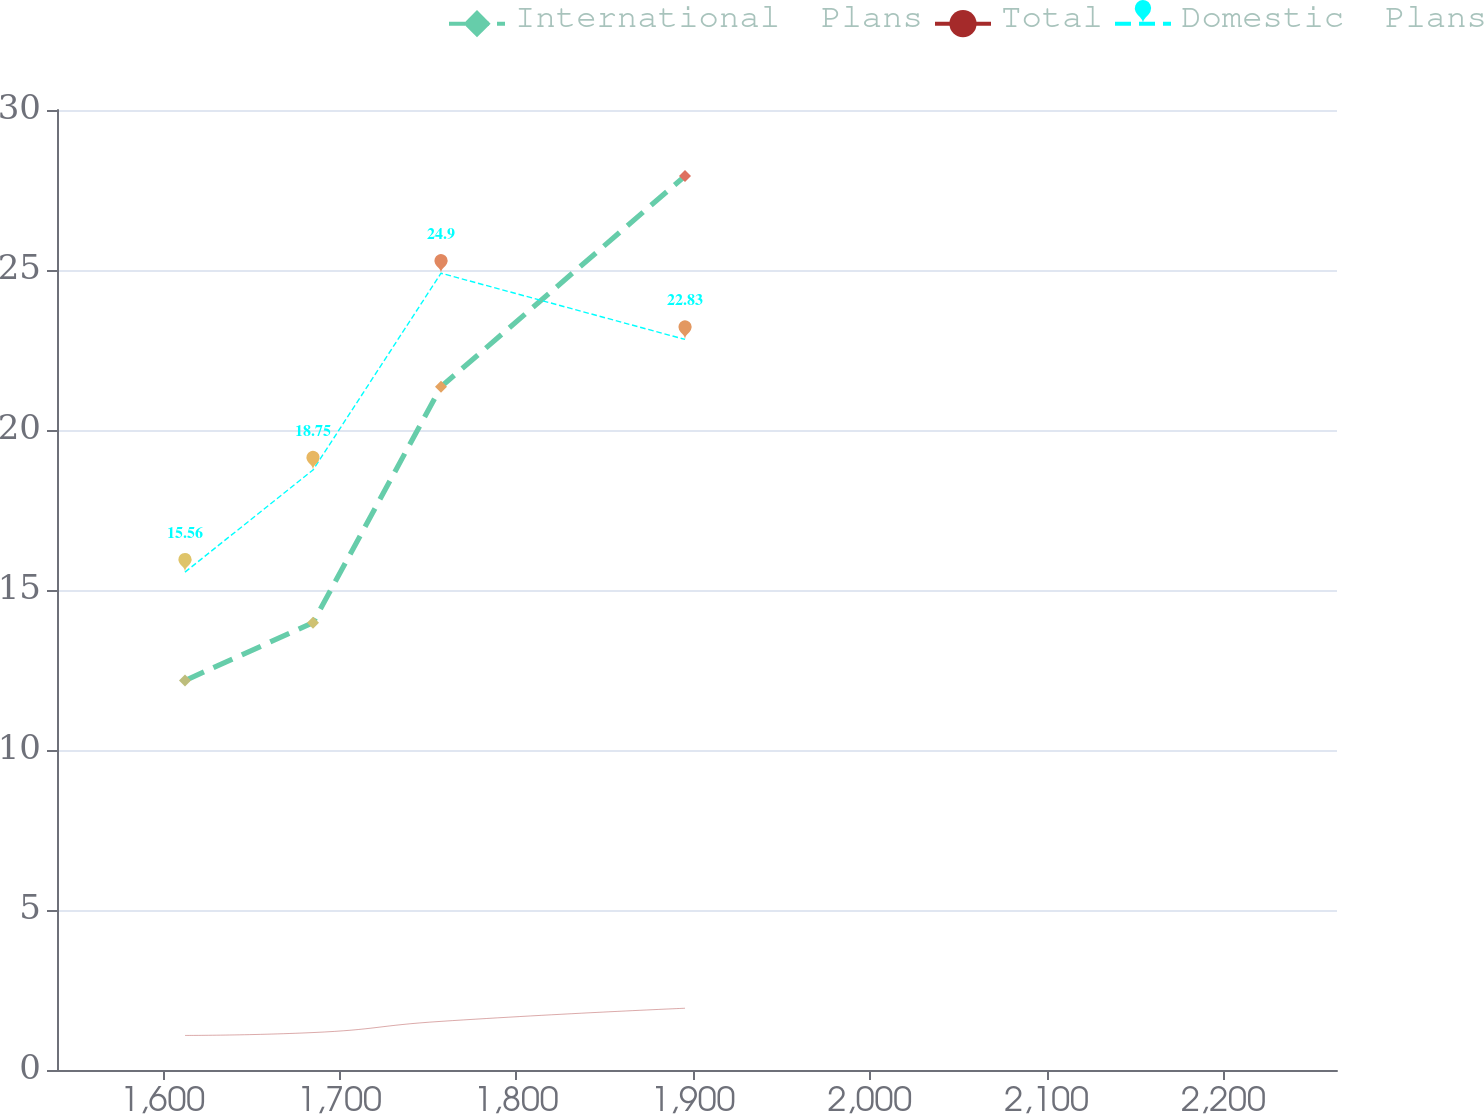<chart> <loc_0><loc_0><loc_500><loc_500><line_chart><ecel><fcel>International  Plans<fcel>Total<fcel>Domestic  Plans<nl><fcel>1612.62<fcel>12.17<fcel>1.08<fcel>15.56<nl><fcel>1685.03<fcel>13.98<fcel>1.17<fcel>18.75<nl><fcel>1757.44<fcel>21.35<fcel>1.52<fcel>24.9<nl><fcel>1895.48<fcel>27.94<fcel>1.93<fcel>22.83<nl><fcel>2336.7<fcel>30.25<fcel>1.79<fcel>32.37<nl></chart> 